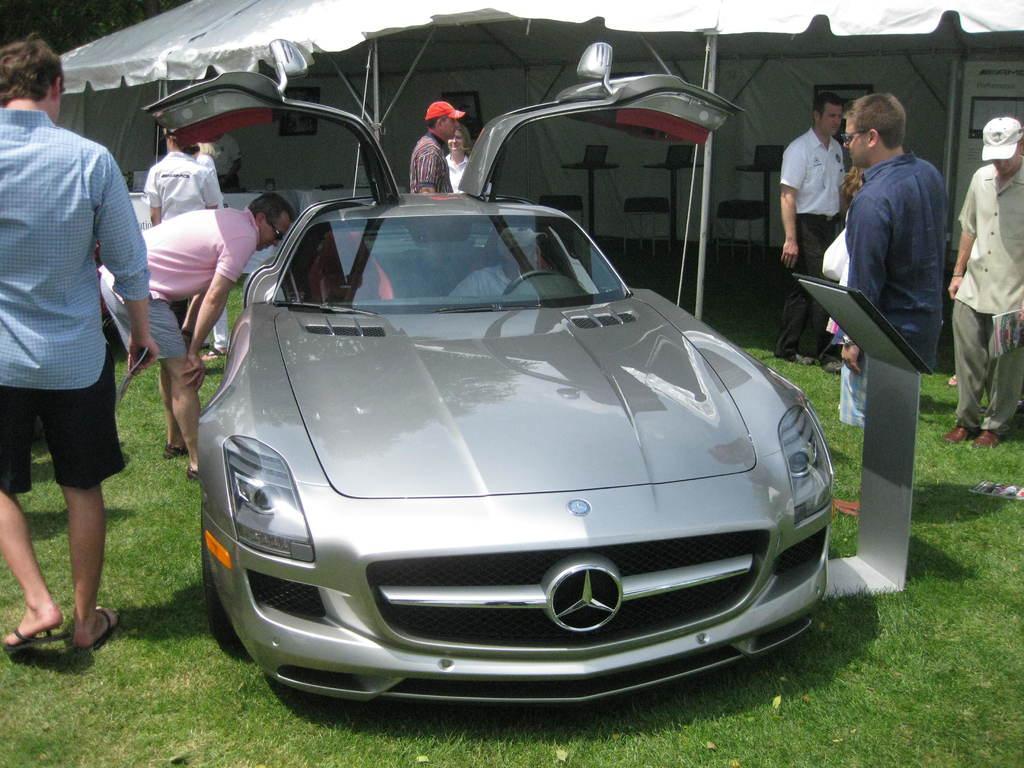Could you give a brief overview of what you see in this image? In this image we can see a few people, there are chairs, there is a car, a tent, also we can see the grass. 